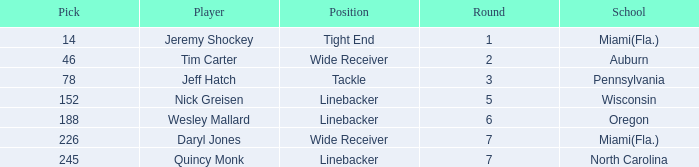From what school was the player drafted in round 3? Pennsylvania. 